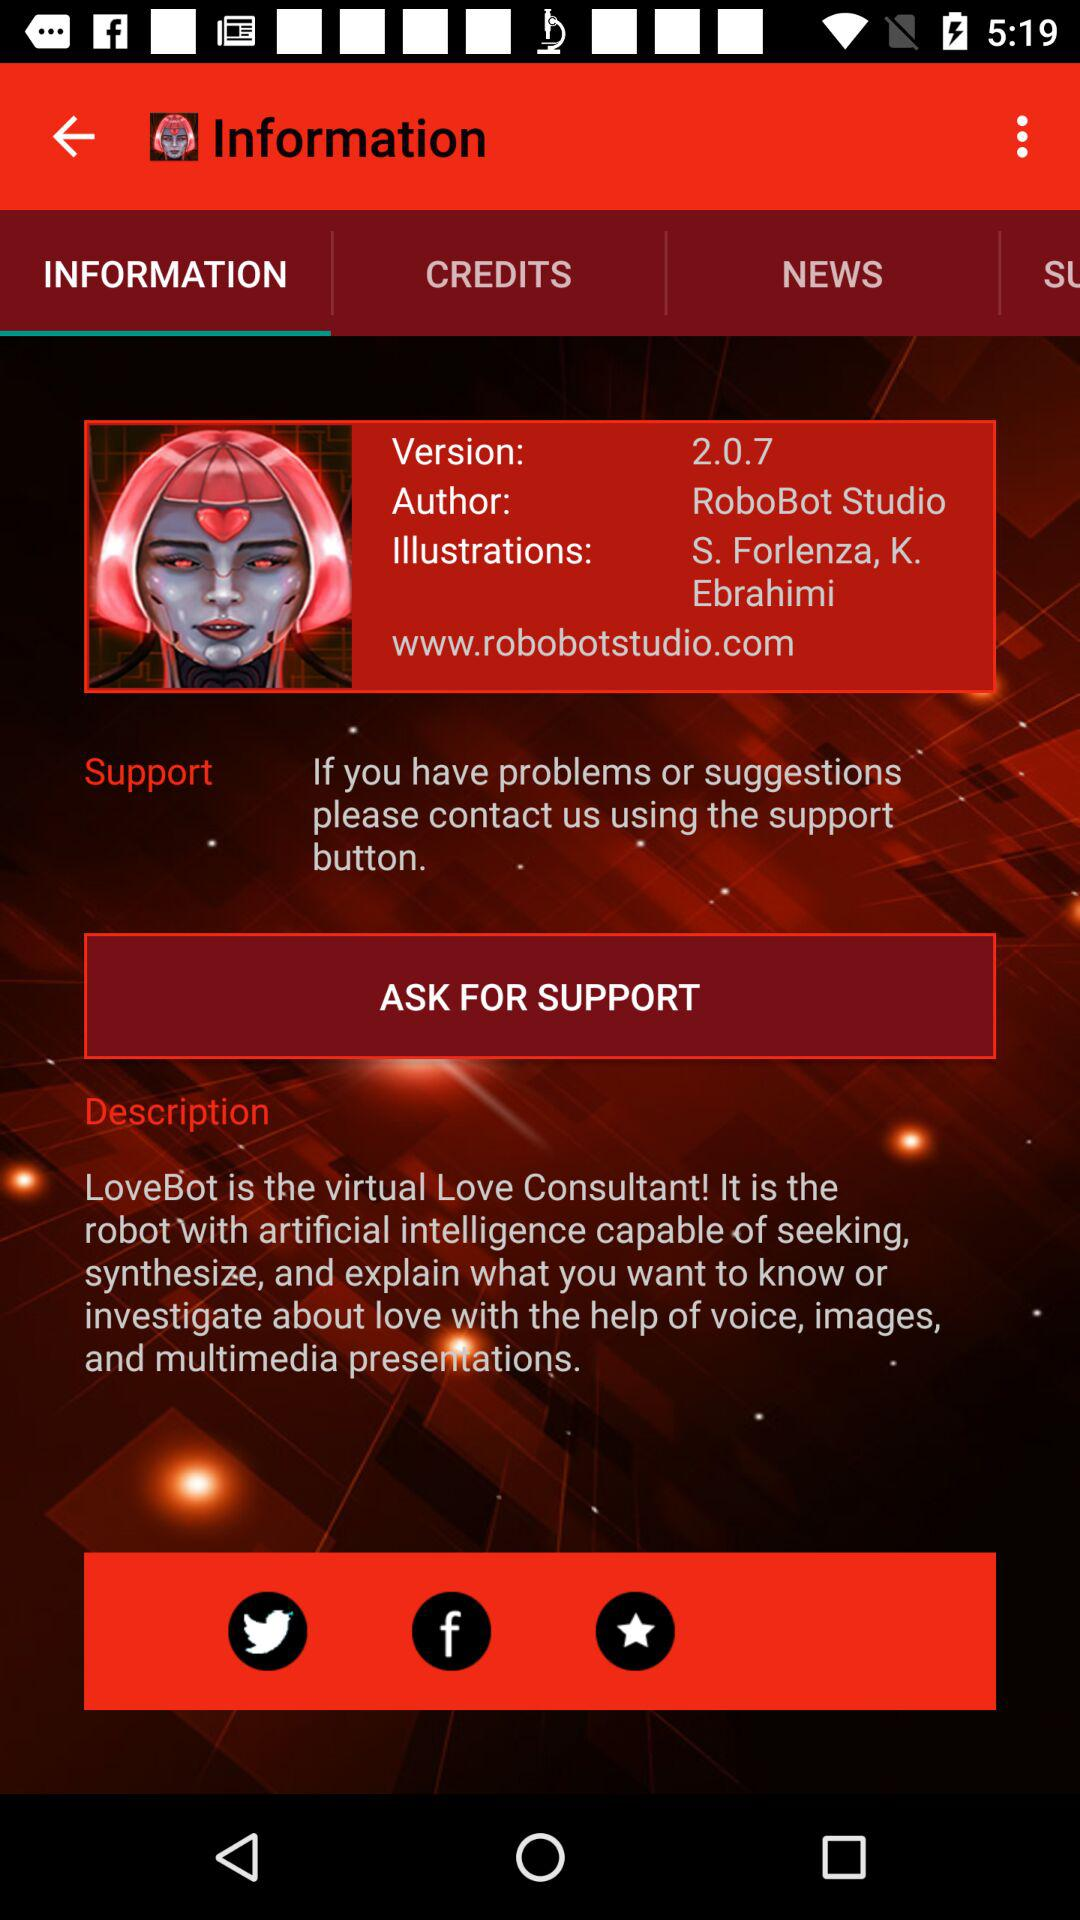By whom is the illustration given? The illustration is given by S. Forlenza and K. Ebrahimi. 